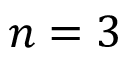Convert formula to latex. <formula><loc_0><loc_0><loc_500><loc_500>n = 3</formula> 